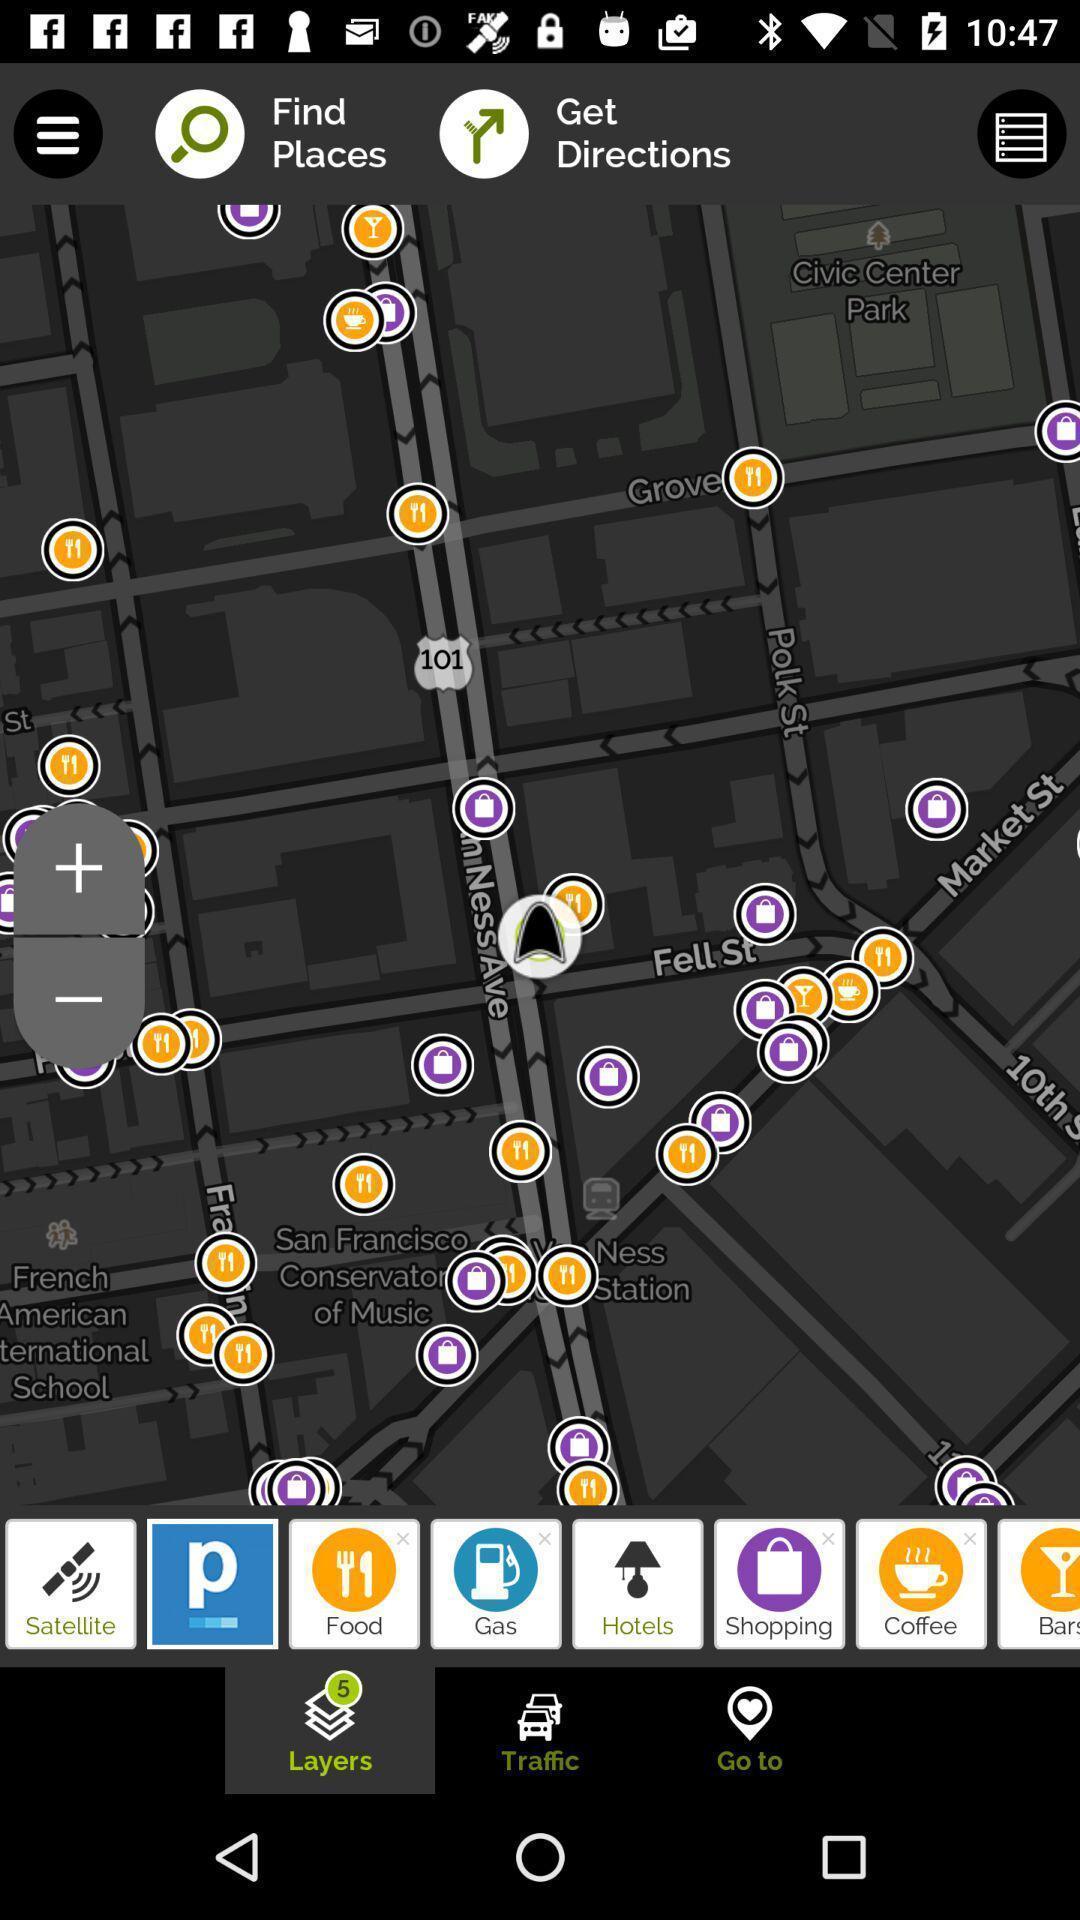Explain the elements present in this screenshot. Page displaying the maps. 